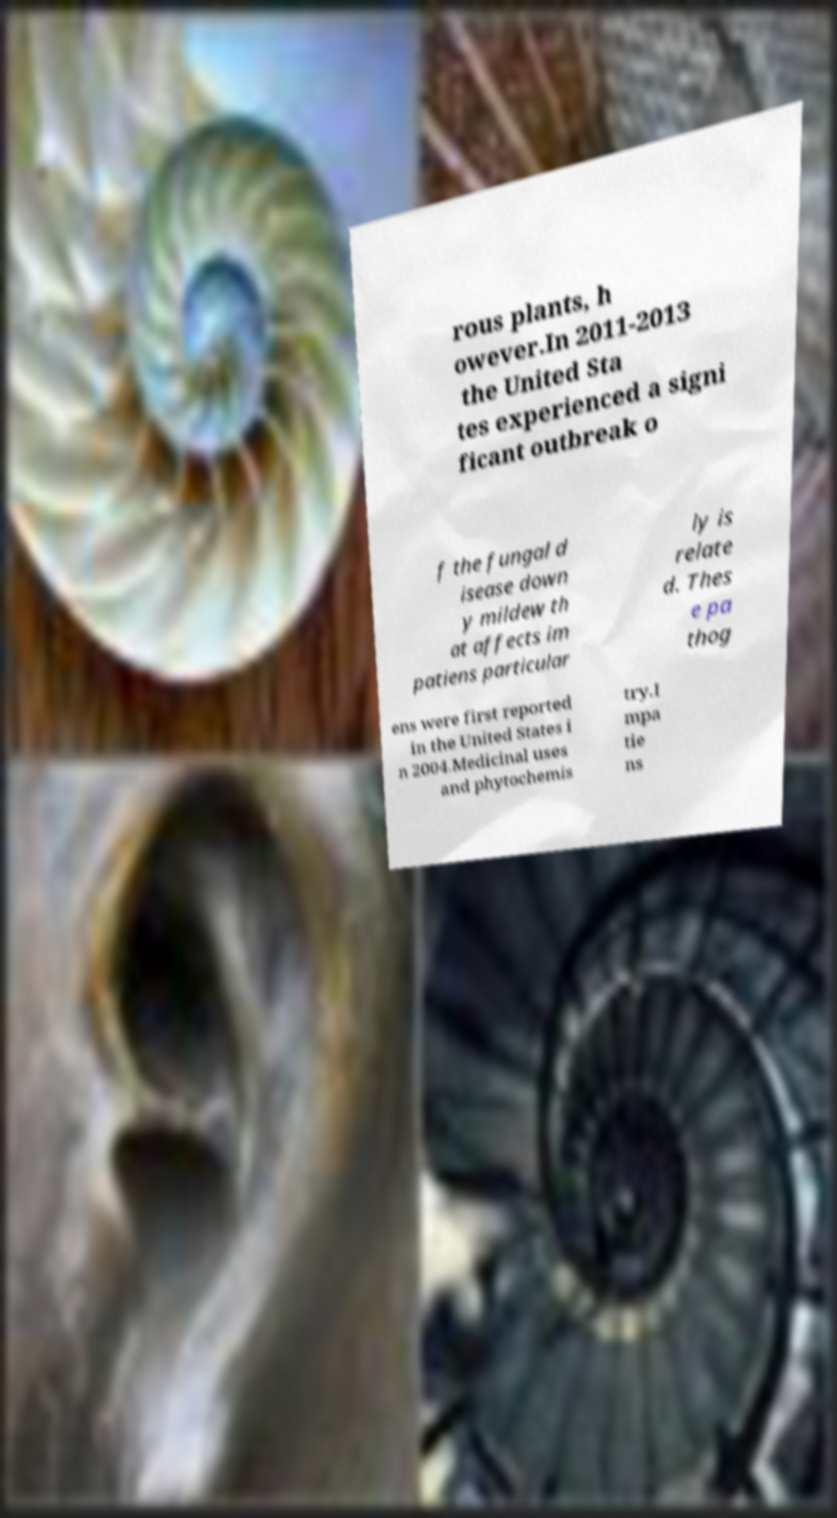Could you extract and type out the text from this image? rous plants, h owever.In 2011-2013 the United Sta tes experienced a signi ficant outbreak o f the fungal d isease down y mildew th at affects im patiens particular ly is relate d. Thes e pa thog ens were first reported in the United States i n 2004.Medicinal uses and phytochemis try.I mpa tie ns 